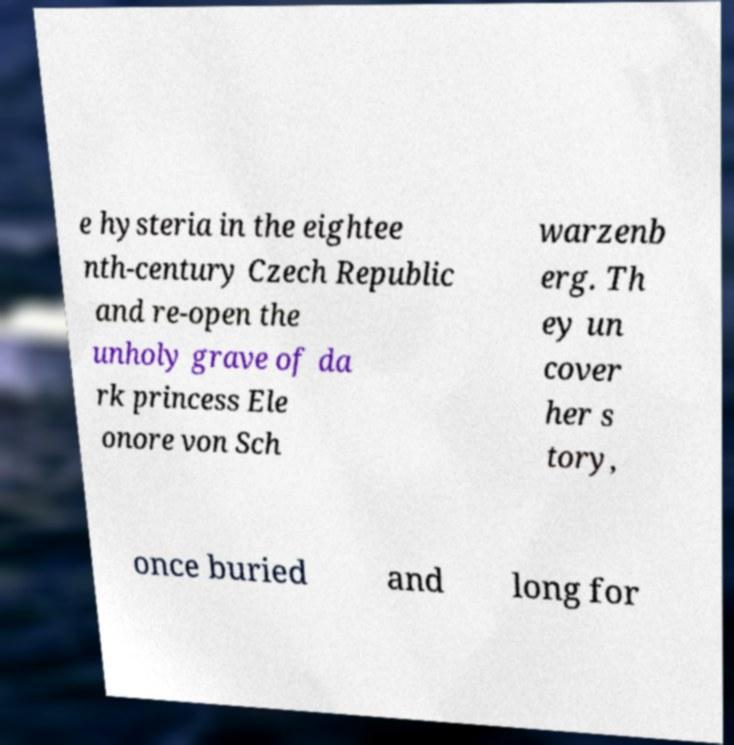Could you extract and type out the text from this image? e hysteria in the eightee nth-century Czech Republic and re-open the unholy grave of da rk princess Ele onore von Sch warzenb erg. Th ey un cover her s tory, once buried and long for 